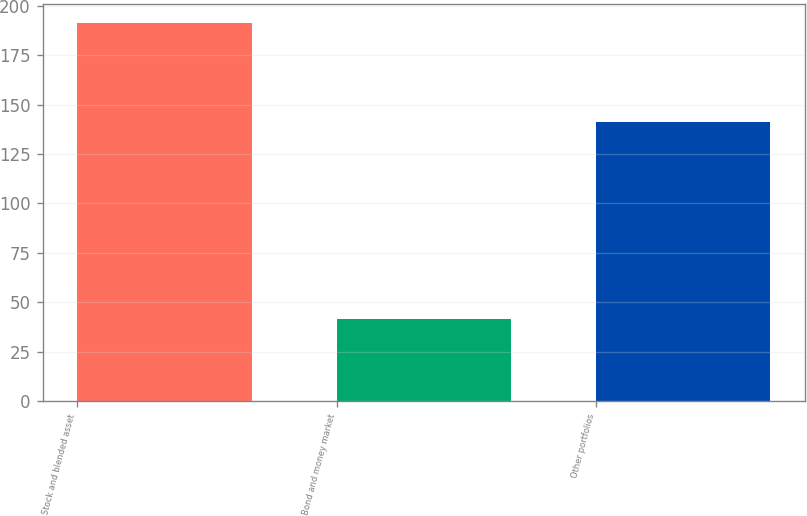Convert chart to OTSL. <chart><loc_0><loc_0><loc_500><loc_500><bar_chart><fcel>Stock and blended asset<fcel>Bond and money market<fcel>Other portfolios<nl><fcel>191.1<fcel>41.7<fcel>141.4<nl></chart> 